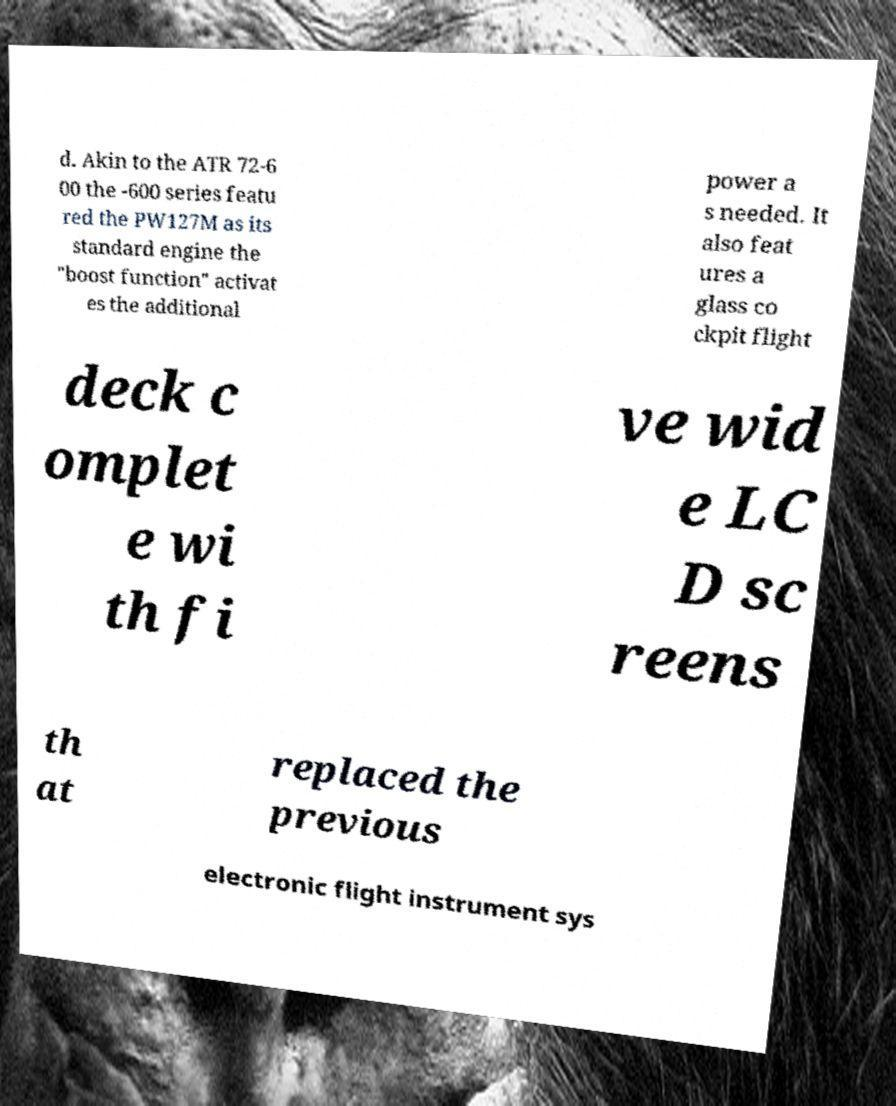Could you assist in decoding the text presented in this image and type it out clearly? d. Akin to the ATR 72-6 00 the -600 series featu red the PW127M as its standard engine the "boost function" activat es the additional power a s needed. It also feat ures a glass co ckpit flight deck c omplet e wi th fi ve wid e LC D sc reens th at replaced the previous electronic flight instrument sys 